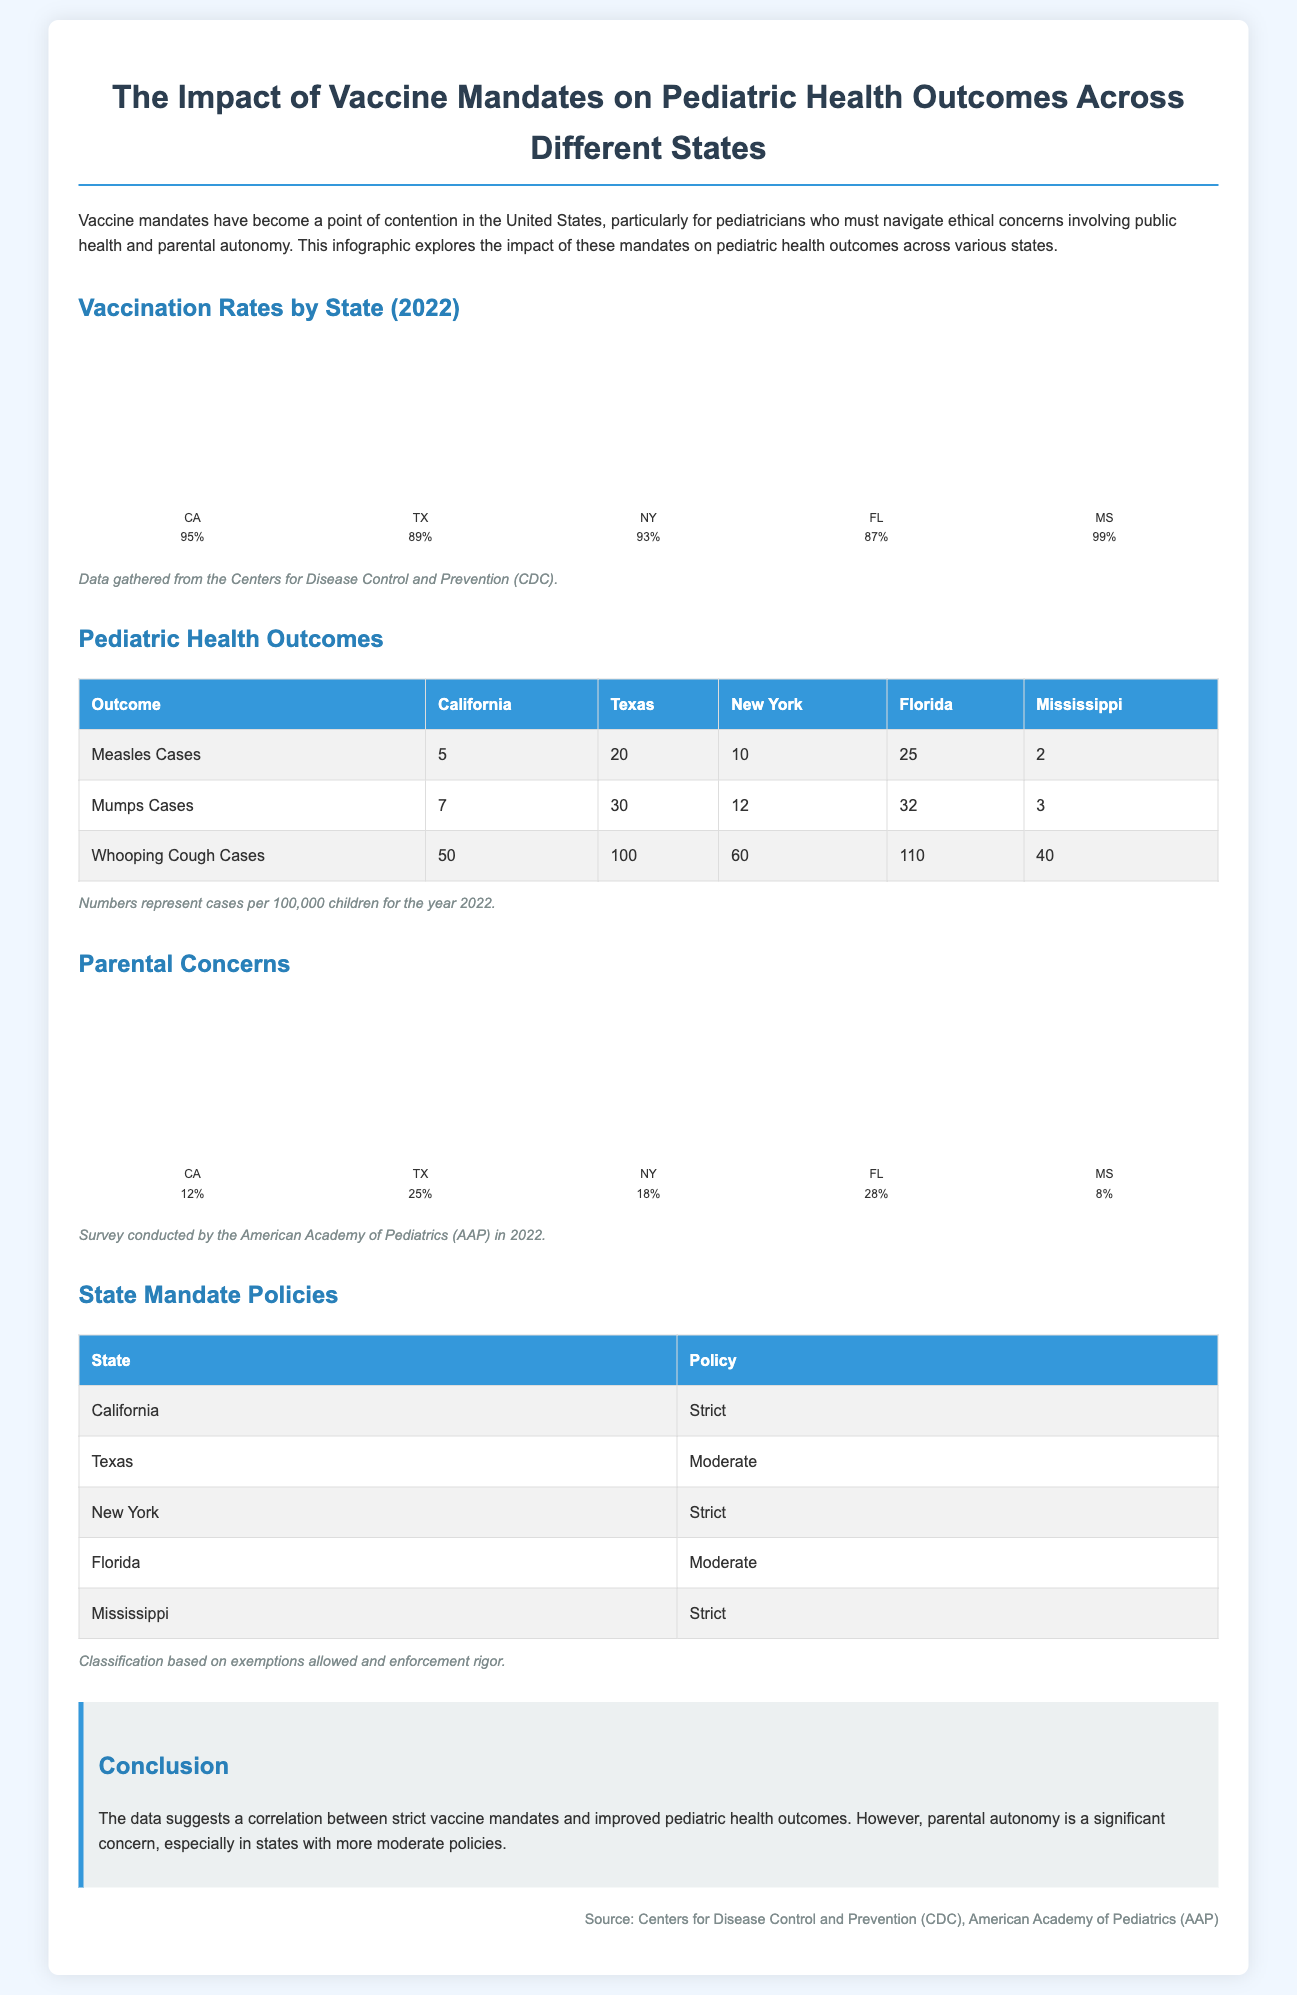What is the vaccination rate in California? The vaccination rate for California in 2022 is listed as 95%.
Answer: 95% How many measles cases were reported in Texas? According to the document, Texas reported 20 measles cases per 100,000 children.
Answer: 20 Which state has the highest number of whooping cough cases? The data shows that Florida has the highest number of whooping cough cases with 110 per 100,000 children.
Answer: Florida What percentage of parents in Florida expressed concerns about vaccines? The document indicates that 28% of parents in Florida expressed concerns regarding vaccines.
Answer: 28% How is the vaccine mandate policy classified in Mississippi? Mississippi's vaccine mandate policy is classified as Strict.
Answer: Strict What is the total number of mumps cases in California and New York combined? Adding the cases: 7 (California) + 12 (New York) gives a total of 19 mumps cases combined.
Answer: 19 Which state has the lowest vaccination rate? Mississippi has the highest vaccination rate at 99%, while Texas has 89%, making it the lowest percentage among those listed.
Answer: Texas What is the main conclusion presented in the infographic? The conclusion suggests a correlation between strict vaccine mandates and improved pediatric health outcomes.
Answer: Correlation What type of survey was referenced for parental concerns? The survey mentioned regarding parental concerns was conducted by the American Academy of Pediatrics (AAP).
Answer: American Academy of Pediatrics (AAP) 